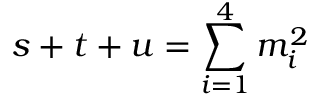<formula> <loc_0><loc_0><loc_500><loc_500>s + t + u = \sum _ { i = 1 } ^ { 4 } m _ { i } ^ { 2 }</formula> 